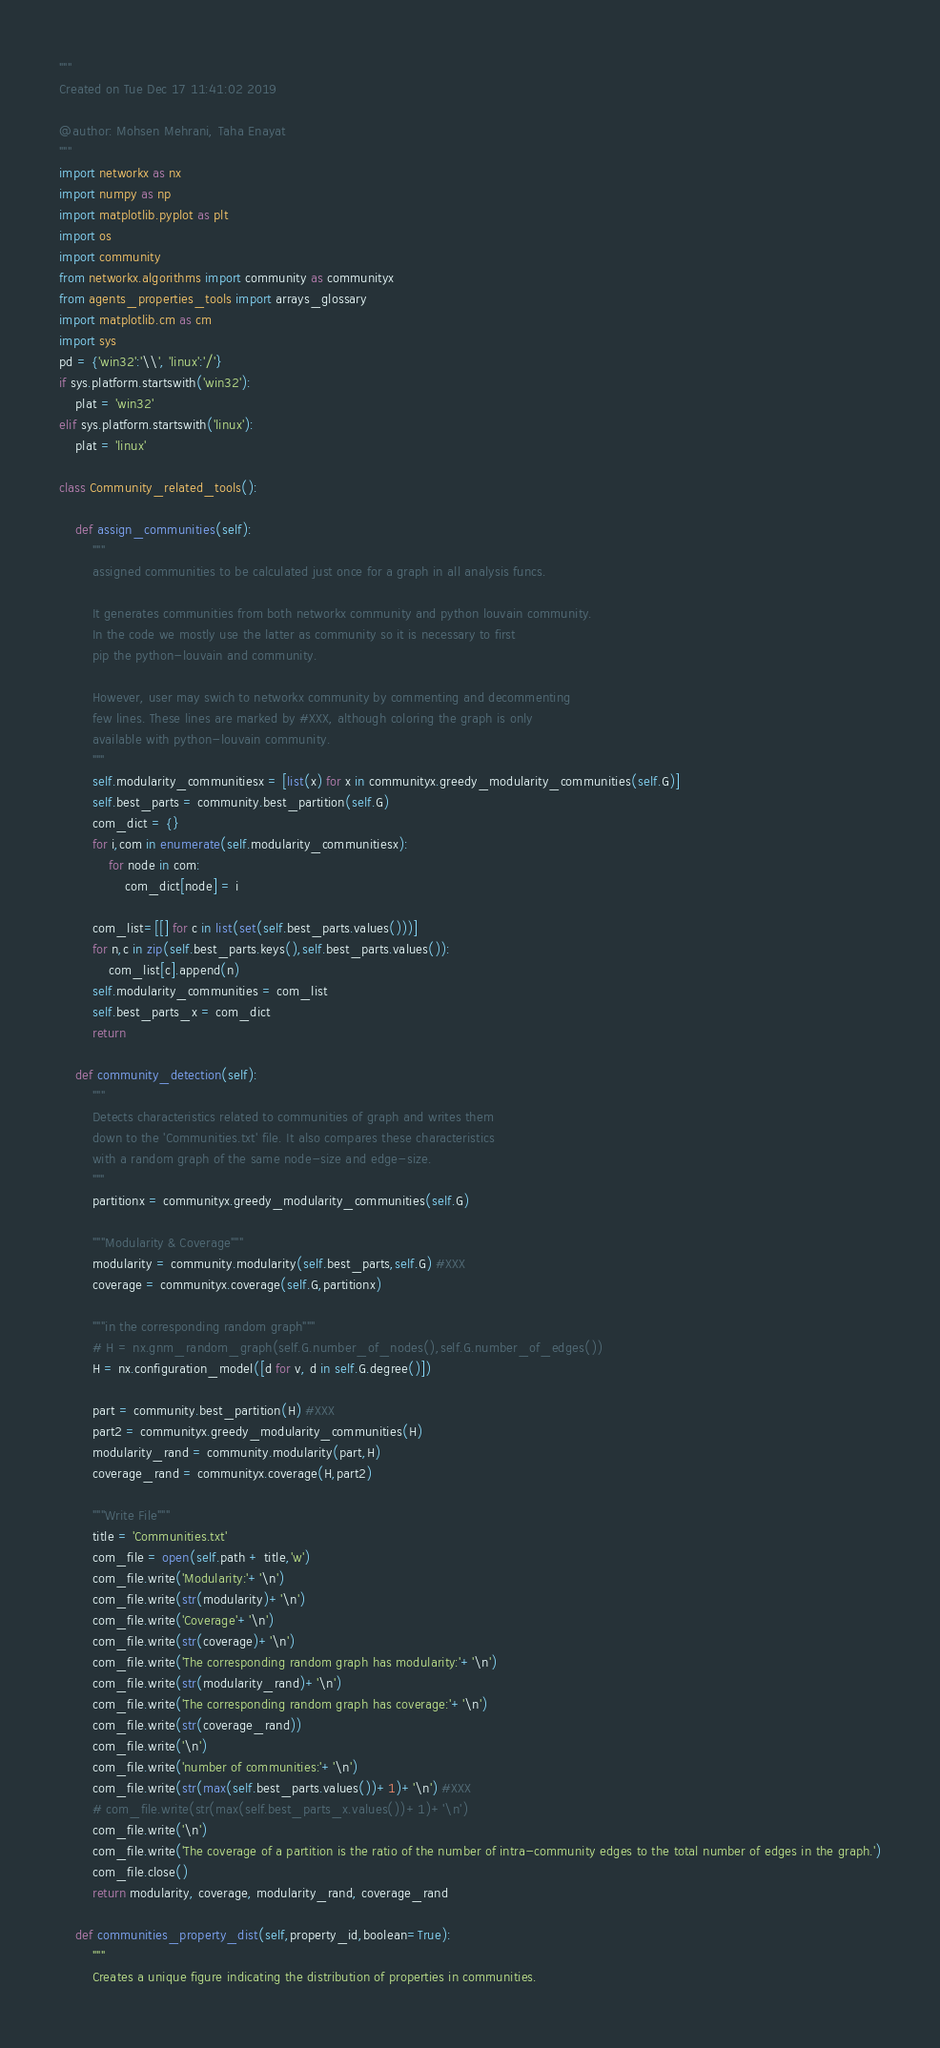Convert code to text. <code><loc_0><loc_0><loc_500><loc_500><_Python_>"""
Created on Tue Dec 17 11:41:02 2019

@author: Mohsen Mehrani, Taha Enayat
"""
import networkx as nx
import numpy as np
import matplotlib.pyplot as plt
import os
import community
from networkx.algorithms import community as communityx
from agents_properties_tools import arrays_glossary
import matplotlib.cm as cm
import sys
pd = {'win32':'\\', 'linux':'/'}
if sys.platform.startswith('win32'):
    plat = 'win32'
elif sys.platform.startswith('linux'):
    plat = 'linux'

class Community_related_tools():
    
    def assign_communities(self):
        """
        assigned communities to be calculated just once for a graph in all analysis funcs.
        
        It generates communities from both networkx community and python louvain community.
        In the code we mostly use the latter as community so it is necessary to first 
        pip the python-louvain and community.
        
        However, user may swich to networkx community by commenting and decommenting 
        few lines. These lines are marked by #XXX, although coloring the graph is only
        available with python-louvain community.
        """
        self.modularity_communitiesx = [list(x) for x in communityx.greedy_modularity_communities(self.G)]
        self.best_parts = community.best_partition(self.G)
        com_dict = {}
        for i,com in enumerate(self.modularity_communitiesx):
            for node in com:
                com_dict[node] = i
        
        com_list=[[] for c in list(set(self.best_parts.values()))]
        for n,c in zip(self.best_parts.keys(),self.best_parts.values()):
            com_list[c].append(n)
        self.modularity_communities = com_list
        self.best_parts_x = com_dict
        return
    
    def community_detection(self):
        """
        Detects characteristics related to communities of graph and writes them 
        down to the 'Communities.txt' file. It also compares these characteristics
        with a random graph of the same node-size and edge-size.
        """
        partitionx = communityx.greedy_modularity_communities(self.G)
        
        """Modularity & Coverage"""
        modularity = community.modularity(self.best_parts,self.G) #XXX
        coverage = communityx.coverage(self.G,partitionx)
        
        """in the corresponding random graph"""
        # H = nx.gnm_random_graph(self.G.number_of_nodes(),self.G.number_of_edges())
        H = nx.configuration_model([d for v, d in self.G.degree()]) 

        part = community.best_partition(H) #XXX
        part2 = communityx.greedy_modularity_communities(H)
        modularity_rand = community.modularity(part,H)
        coverage_rand = communityx.coverage(H,part2)
        
        """Write File"""
        title = 'Communities.txt'
        com_file = open(self.path + title,'w')
        com_file.write('Modularity:'+'\n')
        com_file.write(str(modularity)+'\n')
        com_file.write('Coverage'+'\n')
        com_file.write(str(coverage)+'\n')
        com_file.write('The corresponding random graph has modularity:'+'\n')
        com_file.write(str(modularity_rand)+'\n')
        com_file.write('The corresponding random graph has coverage:'+'\n')
        com_file.write(str(coverage_rand))
        com_file.write('\n')
        com_file.write('number of communities:'+'\n')
        com_file.write(str(max(self.best_parts.values())+1)+'\n') #XXX
        # com_file.write(str(max(self.best_parts_x.values())+1)+'\n')
        com_file.write('\n')
        com_file.write('The coverage of a partition is the ratio of the number of intra-community edges to the total number of edges in the graph.')
        com_file.close()
        return modularity, coverage, modularity_rand, coverage_rand
    
    def communities_property_dist(self,property_id,boolean=True):
        """
        Creates a unique figure indicating the distribution of properties in communities. </code> 